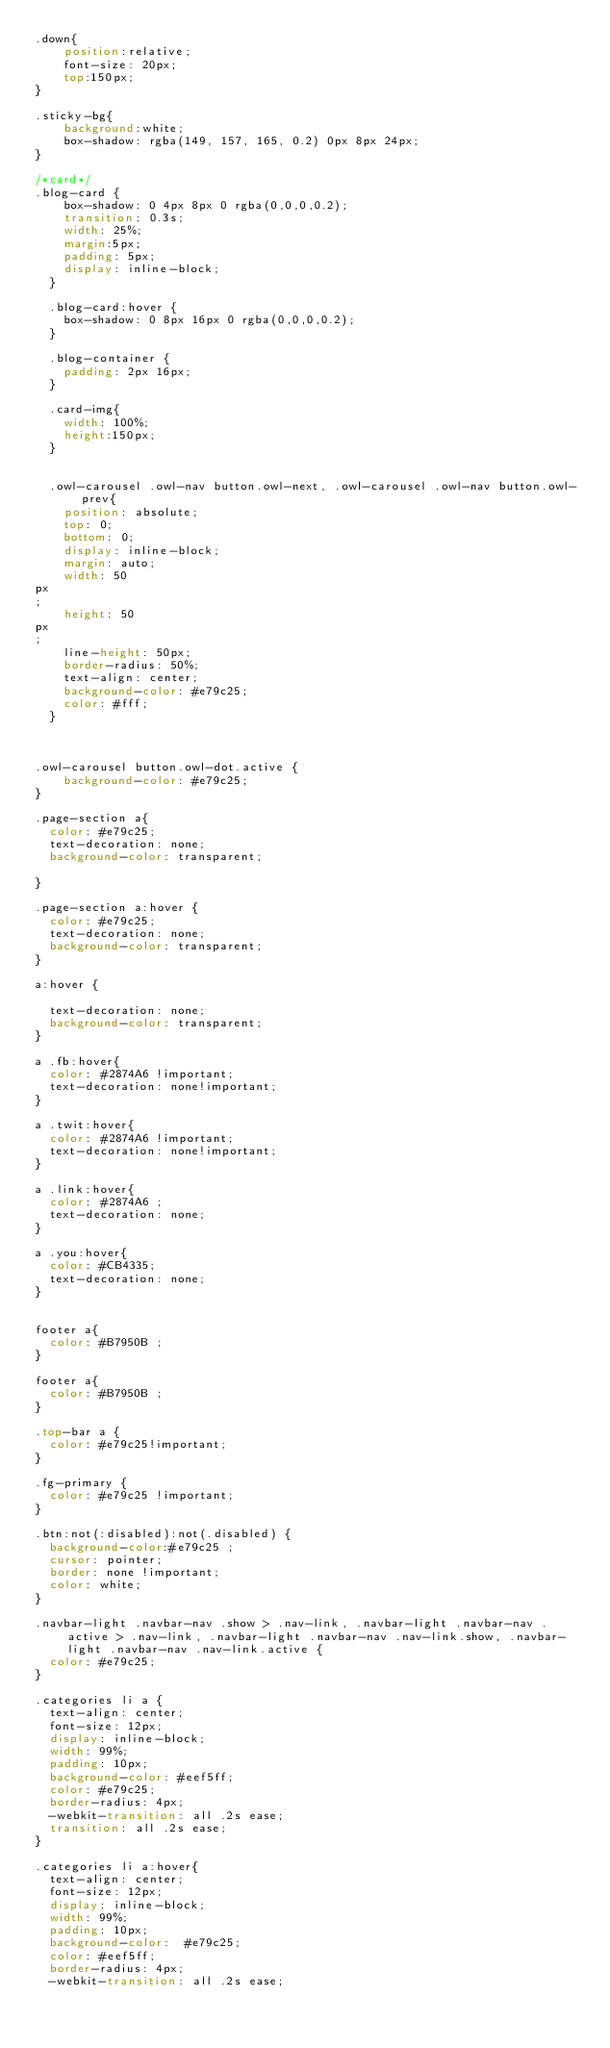Convert code to text. <code><loc_0><loc_0><loc_500><loc_500><_CSS_>.down{
    position:relative;
    font-size: 20px;
    top:150px;
}

.sticky-bg{
    background:white;
    box-shadow: rgba(149, 157, 165, 0.2) 0px 8px 24px;
}

/*card*/
.blog-card {
    box-shadow: 0 4px 8px 0 rgba(0,0,0,0.2);
    transition: 0.3s;
    width: 25%;
    margin:5px;
    padding: 5px;
    display: inline-block;
  }
  
  .blog-card:hover {
    box-shadow: 0 8px 16px 0 rgba(0,0,0,0.2);
  }
  
  .blog-container {
    padding: 2px 16px;
  }

  .card-img{
    width: 100%;
    height:150px;
  }


  .owl-carousel .owl-nav button.owl-next, .owl-carousel .owl-nav button.owl-prev{
    position: absolute;
    top: 0;
    bottom: 0;
    display: inline-block;
    margin: auto;
    width: 50
px
;
    height: 50
px
;
    line-height: 50px;
    border-radius: 50%;
    text-align: center;
    background-color: #e79c25;
    color: #fff;
  }

  

.owl-carousel button.owl-dot.active {
    background-color: #e79c25;
}

.page-section a{
  color: #e79c25;
  text-decoration: none;
  background-color: transparent;
  
}

.page-section a:hover {
  color: #e79c25;
  text-decoration: none;
  background-color: transparent;
}

a:hover {
  
  text-decoration: none;
  background-color: transparent;
}

a .fb:hover{
  color: #2874A6 !important;
  text-decoration: none!important;
}

a .twit:hover{
  color: #2874A6 !important;
  text-decoration: none!important;
}

a .link:hover{
  color: #2874A6 ;
  text-decoration: none;
}

a .you:hover{
  color: #CB4335;
  text-decoration: none;
}


footer a{
  color: #B7950B ;
}

footer a{
  color: #B7950B ;
}

.top-bar a {
  color: #e79c25!important;
}

.fg-primary {
  color: #e79c25 !important;
}

.btn:not(:disabled):not(.disabled) {
  background-color:#e79c25 ;
  cursor: pointer;
  border: none !important;
  color: white;
}

.navbar-light .navbar-nav .show > .nav-link, .navbar-light .navbar-nav .active > .nav-link, .navbar-light .navbar-nav .nav-link.show, .navbar-light .navbar-nav .nav-link.active {
  color: #e79c25;
}

.categories li a {
  text-align: center;
  font-size: 12px;
  display: inline-block;
  width: 99%;
  padding: 10px;
  background-color: #eef5ff;
  color: #e79c25;
  border-radius: 4px;
  -webkit-transition: all .2s ease;
  transition: all .2s ease;
}

.categories li a:hover{
  text-align: center;
  font-size: 12px;
  display: inline-block;
  width: 99%;
  padding: 10px;
  background-color:  #e79c25;
  color: #eef5ff;
  border-radius: 4px;
  -webkit-transition: all .2s ease;</code> 